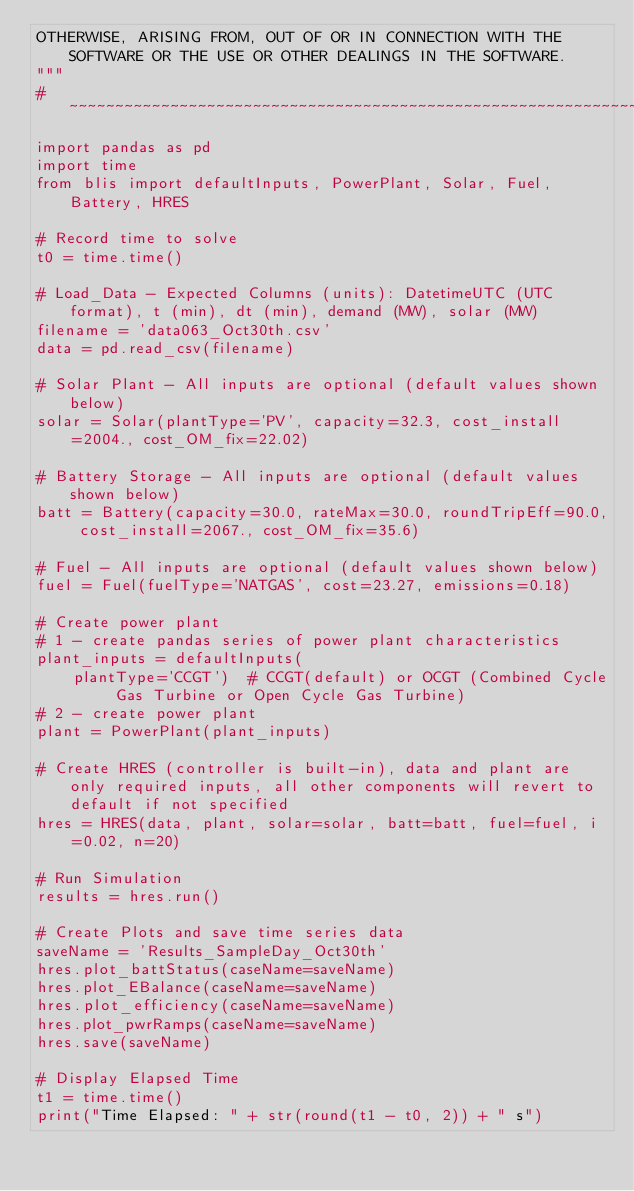<code> <loc_0><loc_0><loc_500><loc_500><_Python_>OTHERWISE, ARISING FROM, OUT OF OR IN CONNECTION WITH THE SOFTWARE OR THE USE OR OTHER DEALINGS IN THE SOFTWARE.
"""
# ~~~~~~~~~~~~~~~~~~~~~~~~~~~~~~~~~~~~~~~~~~~~~~~~~~~~~~~~~~~~~~~~~~~~~~~~~~~~~#
import pandas as pd
import time
from blis import defaultInputs, PowerPlant, Solar, Fuel, Battery, HRES

# Record time to solve
t0 = time.time()

# Load_Data - Expected Columns (units): DatetimeUTC (UTC format), t (min), dt (min), demand (MW), solar (MW)
filename = 'data063_Oct30th.csv'
data = pd.read_csv(filename)

# Solar Plant - All inputs are optional (default values shown below)
solar = Solar(plantType='PV', capacity=32.3, cost_install=2004., cost_OM_fix=22.02)

# Battery Storage - All inputs are optional (default values shown below)
batt = Battery(capacity=30.0, rateMax=30.0, roundTripEff=90.0, cost_install=2067., cost_OM_fix=35.6)

# Fuel - All inputs are optional (default values shown below)
fuel = Fuel(fuelType='NATGAS', cost=23.27, emissions=0.18)

# Create power plant
# 1 - create pandas series of power plant characteristics
plant_inputs = defaultInputs(
    plantType='CCGT')  # CCGT(default) or OCGT (Combined Cycle Gas Turbine or Open Cycle Gas Turbine)
# 2 - create power plant
plant = PowerPlant(plant_inputs)

# Create HRES (controller is built-in), data and plant are only required inputs, all other components will revert to default if not specified
hres = HRES(data, plant, solar=solar, batt=batt, fuel=fuel, i=0.02, n=20)

# Run Simulation
results = hres.run()

# Create Plots and save time series data
saveName = 'Results_SampleDay_Oct30th'
hres.plot_battStatus(caseName=saveName)
hres.plot_EBalance(caseName=saveName)
hres.plot_efficiency(caseName=saveName)
hres.plot_pwrRamps(caseName=saveName)
hres.save(saveName)

# Display Elapsed Time
t1 = time.time()
print("Time Elapsed: " + str(round(t1 - t0, 2)) + " s")
</code> 